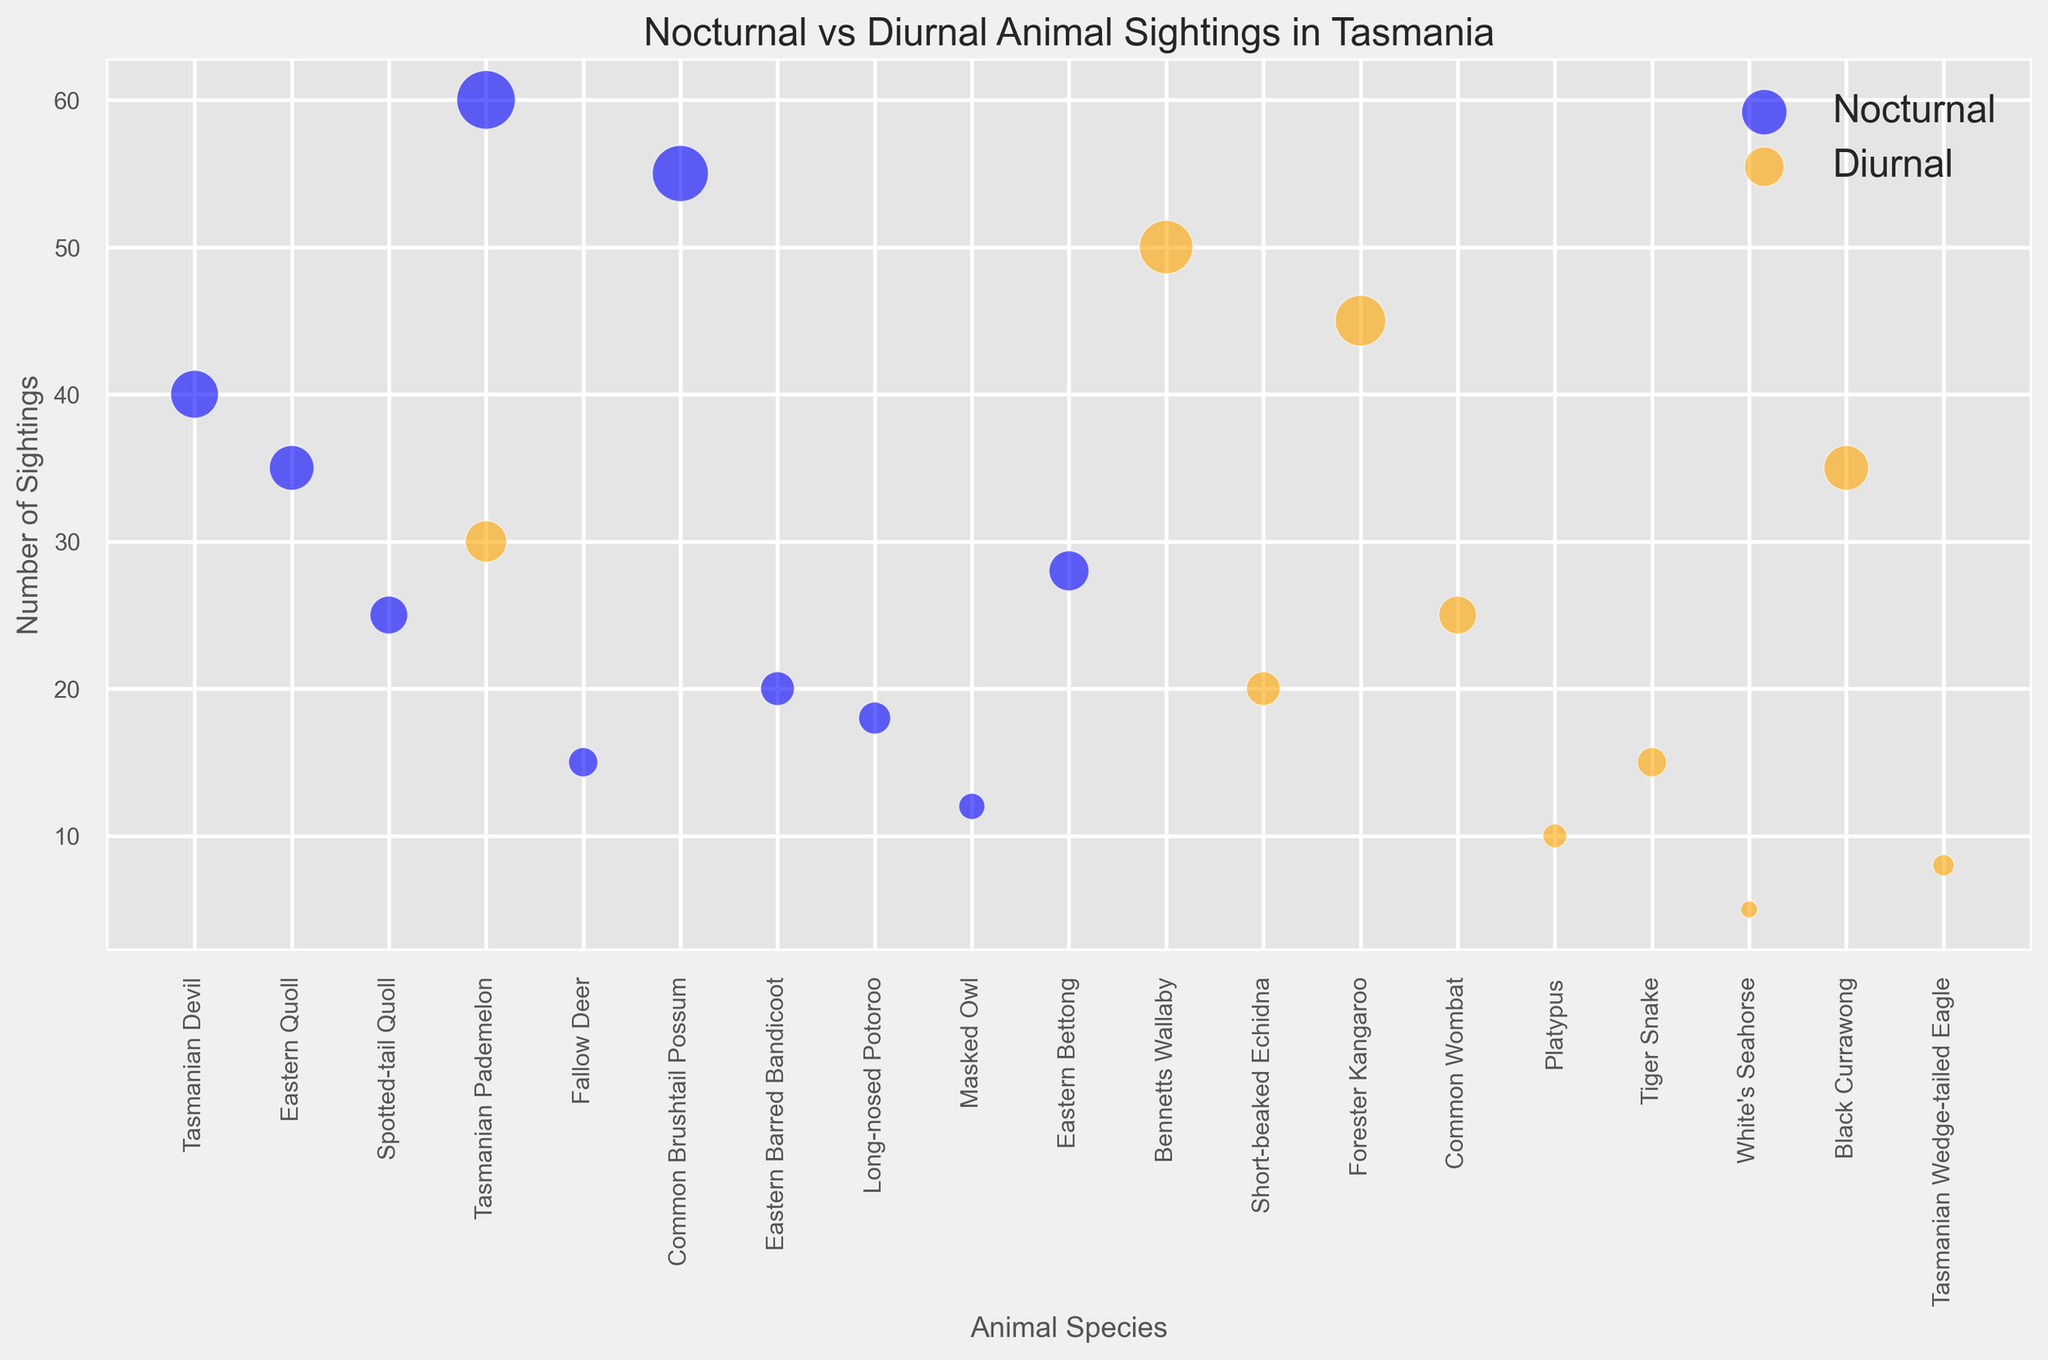Which animal species has the most sightings among nocturnal animals? Check the maximum bubble size among nocturnal animals, which indicates the most sightings. In this case, it’s Tasmanian Pademelon at 60 sightings.
Answer: Tasmanian Pademelon Between Bennetts Wallaby and Forester Kangaroo, which species has fewer sightings? Compare the bubble sizes for Bennetts Wallaby (diurnal, 50 sightings) and Forester Kangaroo (diurnal, 45 sightings). Forester Kangaroo has fewer sightings.
Answer: Forester Kangaroo Which diurnal animal has the smallest number of sightings? Look for the smallest bubble among the diurnal animals. White's Seahorse has the smallest number of sightings with a bubble size of 5.
Answer: White's Seahorse What is the total number of sightings for nocturnal animals? Sum the number of sightings for all nocturnal animals (40+35+25+60+15+55+20+18+12+28). The total is 308.
Answer: 308 How many diurnal animal species have more than 20 sightings? Count the diurnal species with sightings greater than 20. Bennetts Wallaby (50), Forester Kangaroo (45), Black Currawong (35), and Common Wombat (25) qualify. The answer is 4.
Answer: 4 Which has more sightings: the sum of all diurnal species or the sum of all nocturnal species? Sum the sightings for diurnal species (50+30+20+45+25+10+15+5+35+8) = 243 and compare it with the sum of nocturnal species (308). Nocturnal species have more sightings.
Answer: Nocturnal species Which animal is observed in both nocturnal and diurnal conditions? Identify any species listed under both nocturnal and diurnal. Tasmanian Pademelon is observed in both conditions.
Answer: Tasmanian Pademelon Among nocturnal animals, which species has sightings closest to the average number of sightings for nocturnal animals? First, calculate the average of nocturnal sightings, which is 308/10 ≈ 30.8. Then, compare sightings: Eastern Barred Bandicoot (20), Tasmanian Devil (40), etc. Eastern Bettong has 28, closest to 30.8.
Answer: Eastern Bettong Compare the number of sightings between Short-beaked Echidna and Common Brushtail Possum. Which one is higher? Compare the sightings: Short-beaked Echidna (20) and Common Brushtail Possum (55). Common Brushtail Possum has higher sightings.
Answer: Common Brushtail Possum What is the difference in the number of sightings between the species with the highest and lowest sightings among diurnal animals? The highest sighting for diurnal is Bennetts Wallaby (50) and the lowest is White's Seahorse (5). The difference is 50 - 5 = 45.
Answer: 45 